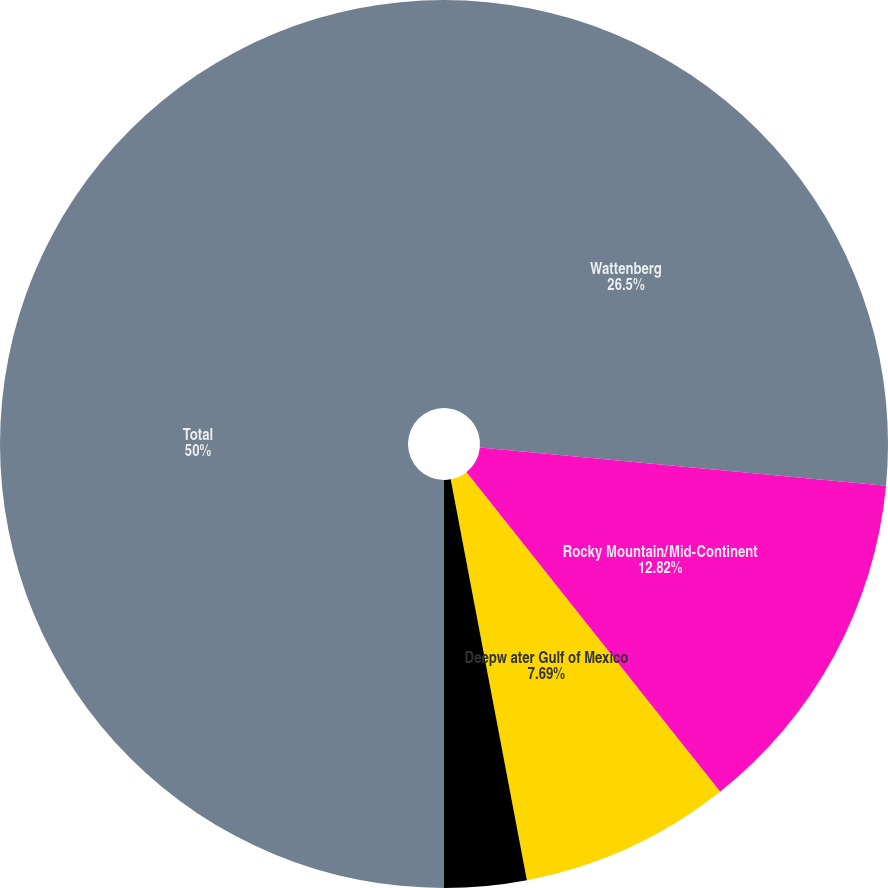Convert chart. <chart><loc_0><loc_0><loc_500><loc_500><pie_chart><fcel>Wattenberg<fcel>Rocky Mountain/Mid-Continent<fcel>Deepw ater Gulf of Mexico<fcel>Gulf Coast and Other<fcel>Total<nl><fcel>26.5%<fcel>12.82%<fcel>7.69%<fcel>2.99%<fcel>50.0%<nl></chart> 